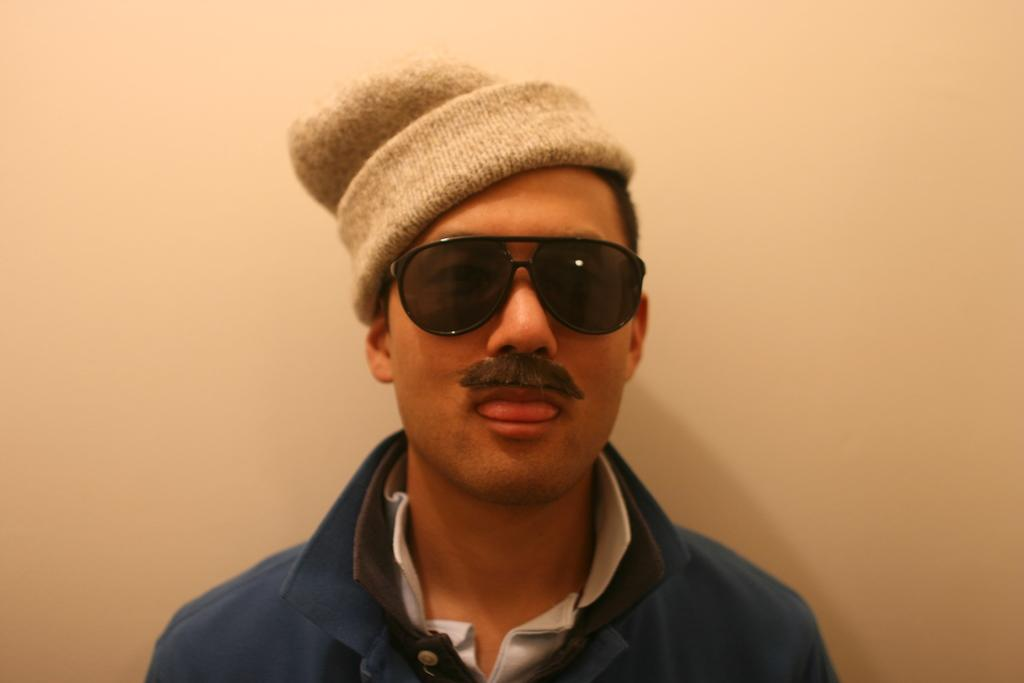Who is present in the image? There is a man in the image. What is the man wearing on his face? The man is wearing goggles. What can be seen in the background of the image? There is a wall in the background of the image. How many pizzas are being pointed at by the books in the image? There are no pizzas or books present in the image. 